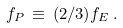<formula> <loc_0><loc_0><loc_500><loc_500>f _ { P } \, \equiv \, ( 2 / 3 ) f _ { E } \, .</formula> 